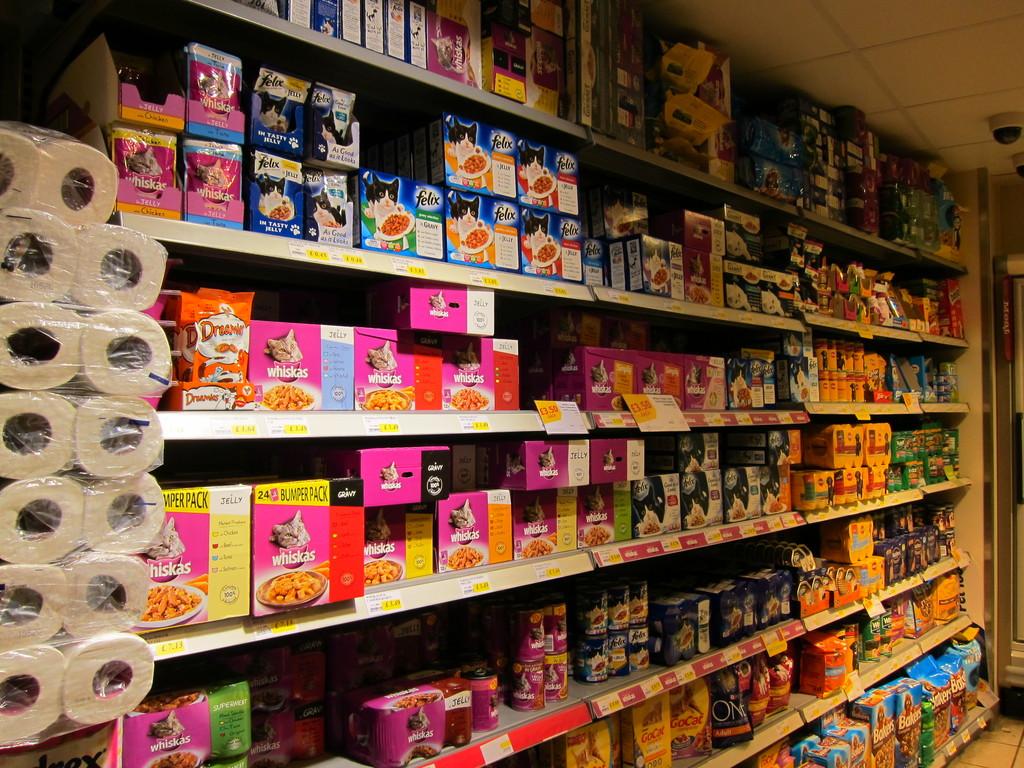How many packs are in the whiskas bumper pack?
Offer a very short reply. 24. 